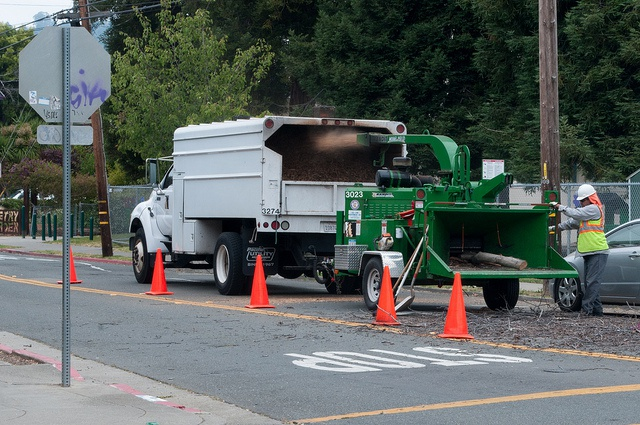Describe the objects in this image and their specific colors. I can see truck in white, black, lightgray, and darkgray tones, stop sign in white, darkgray, and gray tones, car in white, gray, black, blue, and darkgray tones, and people in white, black, gray, lightgreen, and blue tones in this image. 